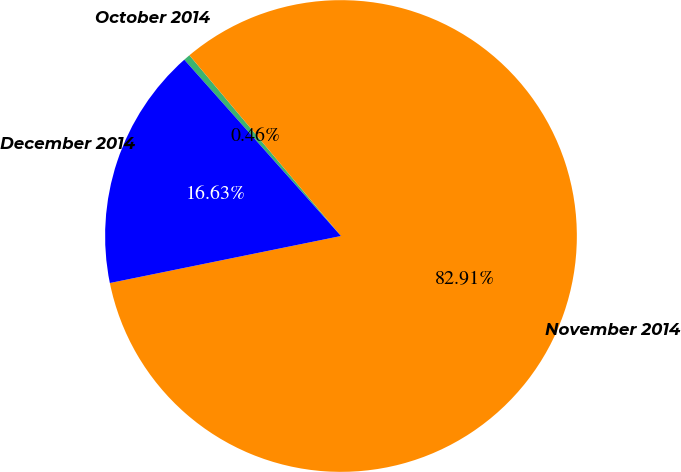<chart> <loc_0><loc_0><loc_500><loc_500><pie_chart><fcel>October 2014<fcel>November 2014<fcel>December 2014<nl><fcel>0.46%<fcel>82.91%<fcel>16.63%<nl></chart> 